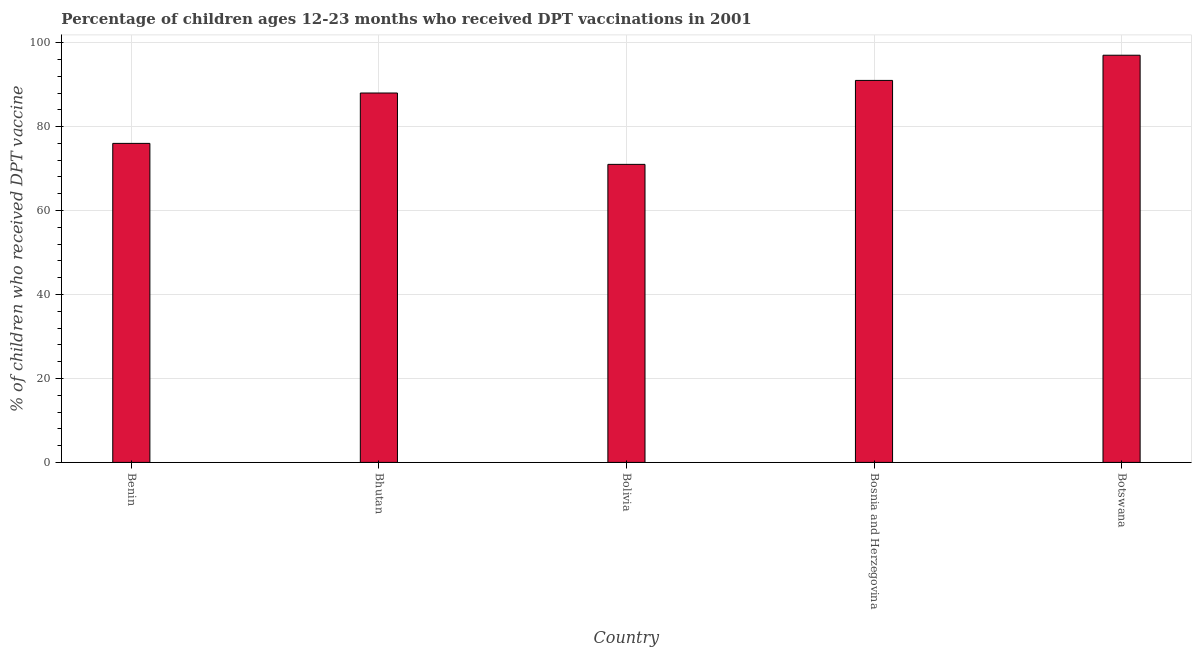Does the graph contain grids?
Your answer should be compact. Yes. What is the title of the graph?
Your response must be concise. Percentage of children ages 12-23 months who received DPT vaccinations in 2001. What is the label or title of the Y-axis?
Offer a terse response. % of children who received DPT vaccine. Across all countries, what is the maximum percentage of children who received dpt vaccine?
Provide a short and direct response. 97. Across all countries, what is the minimum percentage of children who received dpt vaccine?
Keep it short and to the point. 71. In which country was the percentage of children who received dpt vaccine maximum?
Your answer should be very brief. Botswana. What is the sum of the percentage of children who received dpt vaccine?
Give a very brief answer. 423. What is the difference between the percentage of children who received dpt vaccine in Benin and Bolivia?
Your answer should be compact. 5. What is the average percentage of children who received dpt vaccine per country?
Make the answer very short. 84.6. What is the ratio of the percentage of children who received dpt vaccine in Benin to that in Bosnia and Herzegovina?
Provide a succinct answer. 0.83. What is the difference between the highest and the second highest percentage of children who received dpt vaccine?
Give a very brief answer. 6. In how many countries, is the percentage of children who received dpt vaccine greater than the average percentage of children who received dpt vaccine taken over all countries?
Offer a very short reply. 3. Are all the bars in the graph horizontal?
Your answer should be compact. No. What is the difference between two consecutive major ticks on the Y-axis?
Offer a very short reply. 20. What is the % of children who received DPT vaccine of Benin?
Provide a short and direct response. 76. What is the % of children who received DPT vaccine of Bosnia and Herzegovina?
Provide a short and direct response. 91. What is the % of children who received DPT vaccine of Botswana?
Keep it short and to the point. 97. What is the difference between the % of children who received DPT vaccine in Benin and Bhutan?
Make the answer very short. -12. What is the difference between the % of children who received DPT vaccine in Benin and Botswana?
Offer a terse response. -21. What is the difference between the % of children who received DPT vaccine in Bhutan and Bolivia?
Your answer should be compact. 17. What is the difference between the % of children who received DPT vaccine in Bhutan and Bosnia and Herzegovina?
Provide a short and direct response. -3. What is the difference between the % of children who received DPT vaccine in Bhutan and Botswana?
Your answer should be compact. -9. What is the difference between the % of children who received DPT vaccine in Bolivia and Bosnia and Herzegovina?
Keep it short and to the point. -20. What is the difference between the % of children who received DPT vaccine in Bolivia and Botswana?
Provide a succinct answer. -26. What is the difference between the % of children who received DPT vaccine in Bosnia and Herzegovina and Botswana?
Ensure brevity in your answer.  -6. What is the ratio of the % of children who received DPT vaccine in Benin to that in Bhutan?
Make the answer very short. 0.86. What is the ratio of the % of children who received DPT vaccine in Benin to that in Bolivia?
Provide a succinct answer. 1.07. What is the ratio of the % of children who received DPT vaccine in Benin to that in Bosnia and Herzegovina?
Provide a succinct answer. 0.83. What is the ratio of the % of children who received DPT vaccine in Benin to that in Botswana?
Offer a very short reply. 0.78. What is the ratio of the % of children who received DPT vaccine in Bhutan to that in Bolivia?
Make the answer very short. 1.24. What is the ratio of the % of children who received DPT vaccine in Bhutan to that in Bosnia and Herzegovina?
Provide a short and direct response. 0.97. What is the ratio of the % of children who received DPT vaccine in Bhutan to that in Botswana?
Your answer should be very brief. 0.91. What is the ratio of the % of children who received DPT vaccine in Bolivia to that in Bosnia and Herzegovina?
Provide a succinct answer. 0.78. What is the ratio of the % of children who received DPT vaccine in Bolivia to that in Botswana?
Keep it short and to the point. 0.73. What is the ratio of the % of children who received DPT vaccine in Bosnia and Herzegovina to that in Botswana?
Your answer should be very brief. 0.94. 